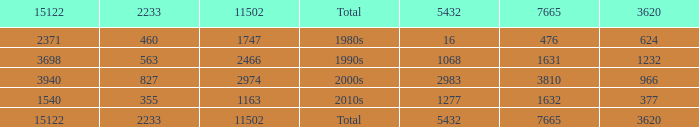What is the average 3620 value that has a 5432 of 1277 and a 15122 less than 1540? None. 